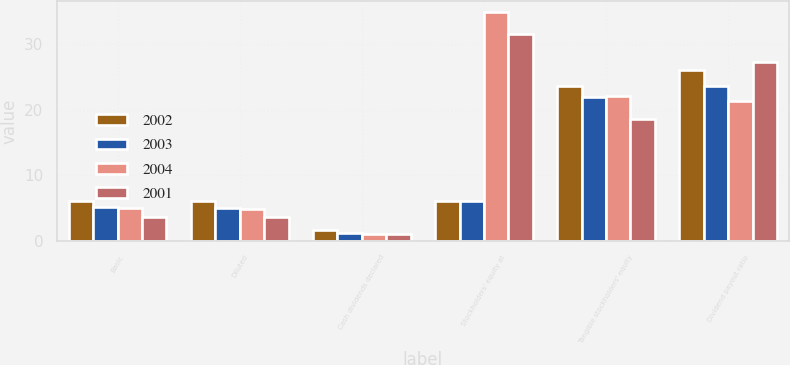Convert chart to OTSL. <chart><loc_0><loc_0><loc_500><loc_500><stacked_bar_chart><ecel><fcel>Basic<fcel>Diluted<fcel>Cash dividends declared<fcel>Stockholders' equity at<fcel>Tangible stockholders' equity<fcel>Dividend payout ratio<nl><fcel>2002<fcel>6.14<fcel>6<fcel>1.6<fcel>6.07<fcel>23.62<fcel>26<nl><fcel>2003<fcel>5.08<fcel>4.95<fcel>1.2<fcel>6.07<fcel>21.97<fcel>23.62<nl><fcel>2004<fcel>4.94<fcel>4.78<fcel>1.05<fcel>34.82<fcel>22.04<fcel>21.24<nl><fcel>2001<fcel>3.69<fcel>3.58<fcel>1<fcel>31.54<fcel>18.54<fcel>27.19<nl></chart> 